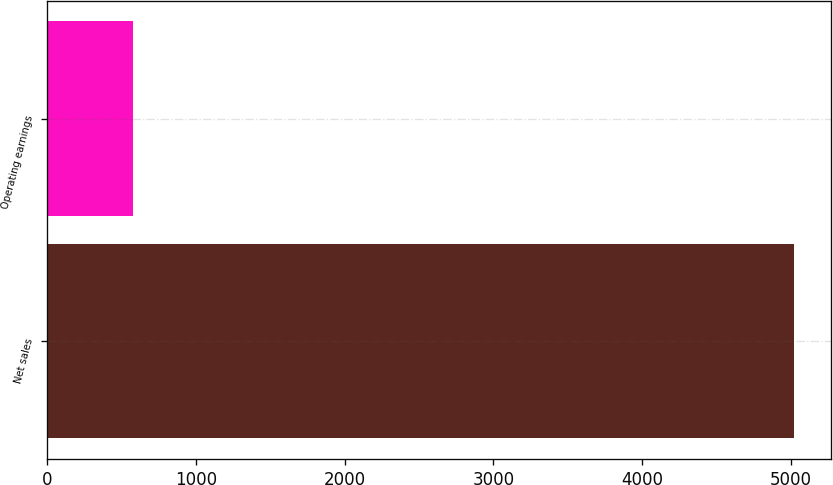<chart> <loc_0><loc_0><loc_500><loc_500><bar_chart><fcel>Net sales<fcel>Operating earnings<nl><fcel>5021<fcel>576<nl></chart> 